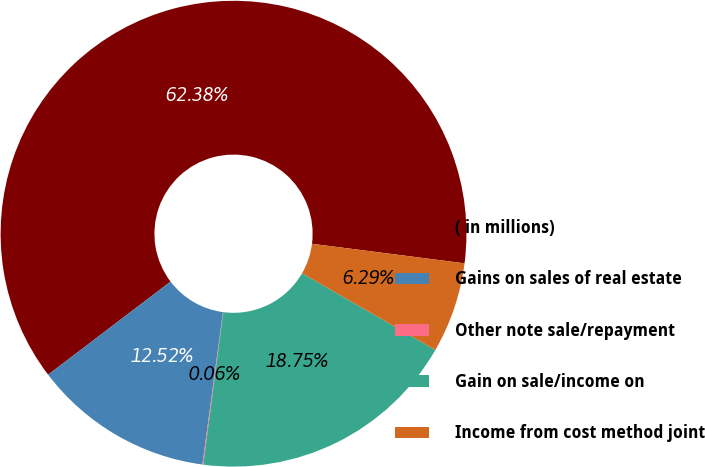Convert chart to OTSL. <chart><loc_0><loc_0><loc_500><loc_500><pie_chart><fcel>( in millions)<fcel>Gains on sales of real estate<fcel>Other note sale/repayment<fcel>Gain on sale/income on<fcel>Income from cost method joint<nl><fcel>62.37%<fcel>12.52%<fcel>0.06%<fcel>18.75%<fcel>6.29%<nl></chart> 